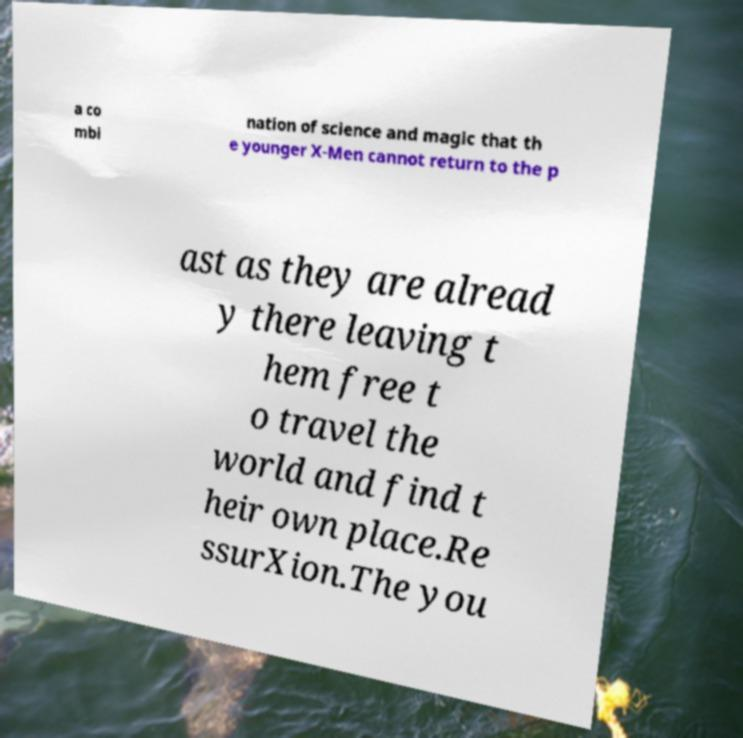What messages or text are displayed in this image? I need them in a readable, typed format. a co mbi nation of science and magic that th e younger X-Men cannot return to the p ast as they are alread y there leaving t hem free t o travel the world and find t heir own place.Re ssurXion.The you 